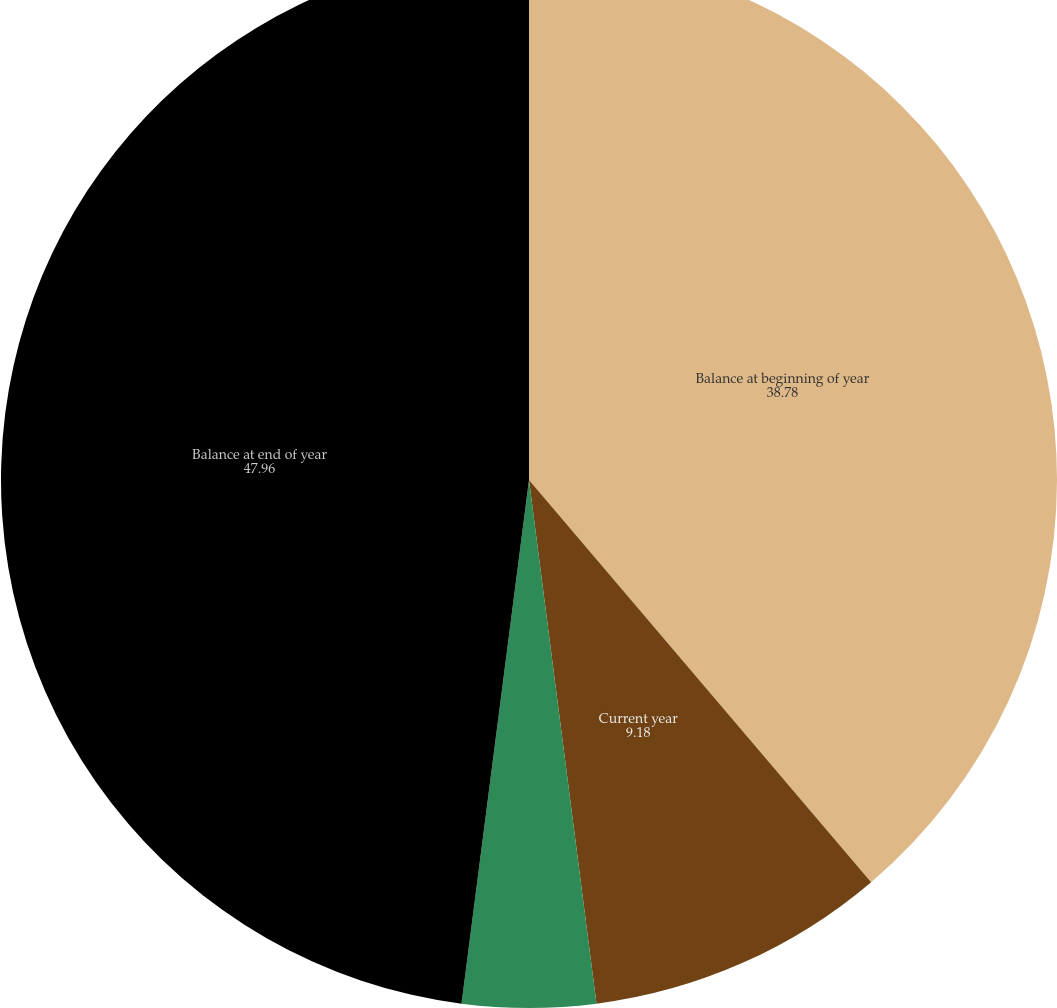Convert chart. <chart><loc_0><loc_0><loc_500><loc_500><pie_chart><fcel>Balance at beginning of year<fcel>Current year<fcel>Expired statute of limitations<fcel>Balance at end of year<nl><fcel>38.78%<fcel>9.18%<fcel>4.08%<fcel>47.96%<nl></chart> 